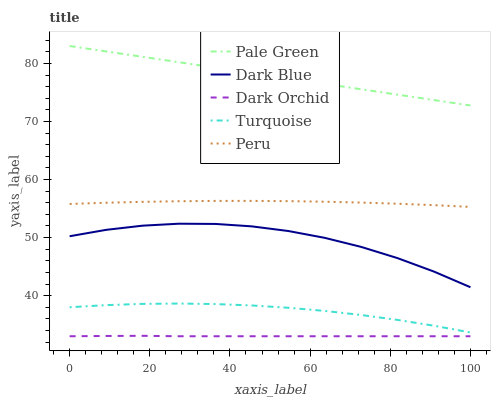Does Dark Orchid have the minimum area under the curve?
Answer yes or no. Yes. Does Pale Green have the maximum area under the curve?
Answer yes or no. Yes. Does Turquoise have the minimum area under the curve?
Answer yes or no. No. Does Turquoise have the maximum area under the curve?
Answer yes or no. No. Is Pale Green the smoothest?
Answer yes or no. Yes. Is Dark Blue the roughest?
Answer yes or no. Yes. Is Turquoise the smoothest?
Answer yes or no. No. Is Turquoise the roughest?
Answer yes or no. No. Does Dark Orchid have the lowest value?
Answer yes or no. Yes. Does Turquoise have the lowest value?
Answer yes or no. No. Does Pale Green have the highest value?
Answer yes or no. Yes. Does Turquoise have the highest value?
Answer yes or no. No. Is Dark Orchid less than Dark Blue?
Answer yes or no. Yes. Is Dark Blue greater than Dark Orchid?
Answer yes or no. Yes. Does Dark Orchid intersect Dark Blue?
Answer yes or no. No. 